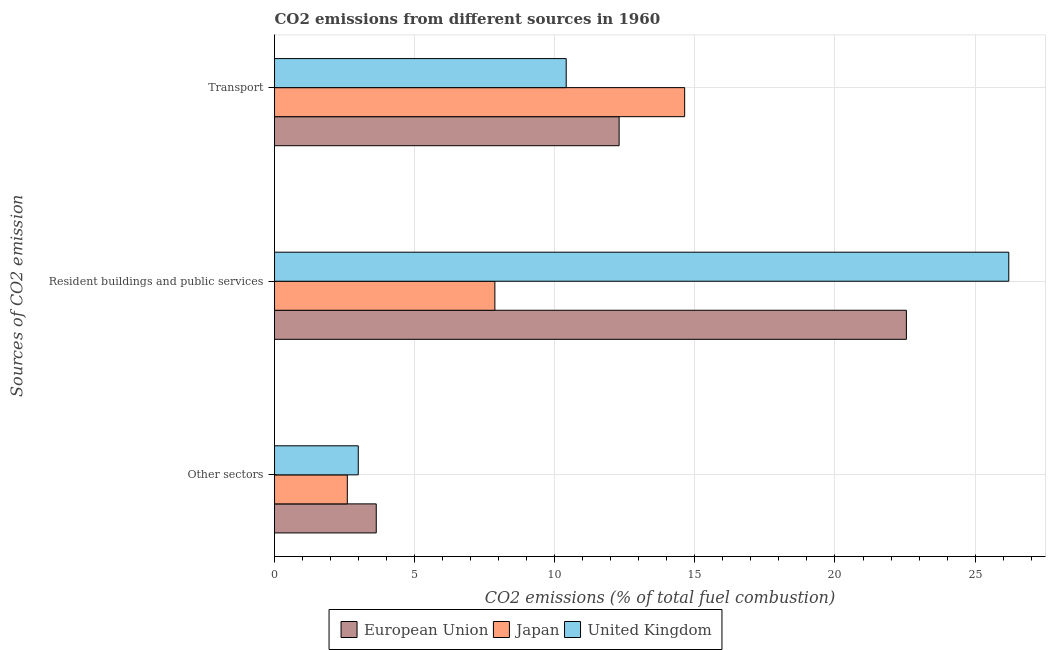What is the label of the 3rd group of bars from the top?
Provide a short and direct response. Other sectors. What is the percentage of co2 emissions from transport in European Union?
Offer a very short reply. 12.3. Across all countries, what is the maximum percentage of co2 emissions from resident buildings and public services?
Your response must be concise. 26.2. Across all countries, what is the minimum percentage of co2 emissions from resident buildings and public services?
Your response must be concise. 7.86. In which country was the percentage of co2 emissions from resident buildings and public services minimum?
Your answer should be compact. Japan. What is the total percentage of co2 emissions from other sectors in the graph?
Provide a short and direct response. 9.22. What is the difference between the percentage of co2 emissions from transport in United Kingdom and that in European Union?
Provide a short and direct response. -1.89. What is the difference between the percentage of co2 emissions from transport in European Union and the percentage of co2 emissions from resident buildings and public services in Japan?
Provide a short and direct response. 4.43. What is the average percentage of co2 emissions from resident buildings and public services per country?
Ensure brevity in your answer.  18.87. What is the difference between the percentage of co2 emissions from transport and percentage of co2 emissions from resident buildings and public services in United Kingdom?
Keep it short and to the point. -15.79. In how many countries, is the percentage of co2 emissions from other sectors greater than 9 %?
Offer a terse response. 0. What is the ratio of the percentage of co2 emissions from transport in European Union to that in United Kingdom?
Keep it short and to the point. 1.18. What is the difference between the highest and the second highest percentage of co2 emissions from resident buildings and public services?
Give a very brief answer. 3.65. What is the difference between the highest and the lowest percentage of co2 emissions from transport?
Provide a succinct answer. 4.23. In how many countries, is the percentage of co2 emissions from transport greater than the average percentage of co2 emissions from transport taken over all countries?
Your answer should be compact. 1. What does the 3rd bar from the bottom in Resident buildings and public services represents?
Make the answer very short. United Kingdom. How many countries are there in the graph?
Provide a succinct answer. 3. Are the values on the major ticks of X-axis written in scientific E-notation?
Provide a succinct answer. No. Does the graph contain any zero values?
Your answer should be very brief. No. What is the title of the graph?
Ensure brevity in your answer.  CO2 emissions from different sources in 1960. What is the label or title of the X-axis?
Your response must be concise. CO2 emissions (% of total fuel combustion). What is the label or title of the Y-axis?
Your answer should be very brief. Sources of CO2 emission. What is the CO2 emissions (% of total fuel combustion) of European Union in Other sectors?
Offer a very short reply. 3.63. What is the CO2 emissions (% of total fuel combustion) in Japan in Other sectors?
Provide a short and direct response. 2.6. What is the CO2 emissions (% of total fuel combustion) of United Kingdom in Other sectors?
Make the answer very short. 2.99. What is the CO2 emissions (% of total fuel combustion) in European Union in Resident buildings and public services?
Your answer should be compact. 22.55. What is the CO2 emissions (% of total fuel combustion) of Japan in Resident buildings and public services?
Offer a very short reply. 7.86. What is the CO2 emissions (% of total fuel combustion) of United Kingdom in Resident buildings and public services?
Offer a very short reply. 26.2. What is the CO2 emissions (% of total fuel combustion) in European Union in Transport?
Make the answer very short. 12.3. What is the CO2 emissions (% of total fuel combustion) in Japan in Transport?
Provide a succinct answer. 14.64. What is the CO2 emissions (% of total fuel combustion) in United Kingdom in Transport?
Give a very brief answer. 10.41. Across all Sources of CO2 emission, what is the maximum CO2 emissions (% of total fuel combustion) of European Union?
Provide a short and direct response. 22.55. Across all Sources of CO2 emission, what is the maximum CO2 emissions (% of total fuel combustion) in Japan?
Give a very brief answer. 14.64. Across all Sources of CO2 emission, what is the maximum CO2 emissions (% of total fuel combustion) in United Kingdom?
Ensure brevity in your answer.  26.2. Across all Sources of CO2 emission, what is the minimum CO2 emissions (% of total fuel combustion) in European Union?
Your response must be concise. 3.63. Across all Sources of CO2 emission, what is the minimum CO2 emissions (% of total fuel combustion) of Japan?
Give a very brief answer. 2.6. Across all Sources of CO2 emission, what is the minimum CO2 emissions (% of total fuel combustion) in United Kingdom?
Provide a short and direct response. 2.99. What is the total CO2 emissions (% of total fuel combustion) in European Union in the graph?
Your answer should be compact. 38.48. What is the total CO2 emissions (% of total fuel combustion) of Japan in the graph?
Offer a terse response. 25.1. What is the total CO2 emissions (% of total fuel combustion) of United Kingdom in the graph?
Ensure brevity in your answer.  39.6. What is the difference between the CO2 emissions (% of total fuel combustion) of European Union in Other sectors and that in Resident buildings and public services?
Your answer should be very brief. -18.92. What is the difference between the CO2 emissions (% of total fuel combustion) of Japan in Other sectors and that in Resident buildings and public services?
Provide a short and direct response. -5.27. What is the difference between the CO2 emissions (% of total fuel combustion) in United Kingdom in Other sectors and that in Resident buildings and public services?
Your answer should be very brief. -23.21. What is the difference between the CO2 emissions (% of total fuel combustion) in European Union in Other sectors and that in Transport?
Your response must be concise. -8.67. What is the difference between the CO2 emissions (% of total fuel combustion) in Japan in Other sectors and that in Transport?
Ensure brevity in your answer.  -12.04. What is the difference between the CO2 emissions (% of total fuel combustion) in United Kingdom in Other sectors and that in Transport?
Provide a succinct answer. -7.42. What is the difference between the CO2 emissions (% of total fuel combustion) of European Union in Resident buildings and public services and that in Transport?
Keep it short and to the point. 10.25. What is the difference between the CO2 emissions (% of total fuel combustion) in Japan in Resident buildings and public services and that in Transport?
Give a very brief answer. -6.77. What is the difference between the CO2 emissions (% of total fuel combustion) in United Kingdom in Resident buildings and public services and that in Transport?
Your answer should be very brief. 15.79. What is the difference between the CO2 emissions (% of total fuel combustion) in European Union in Other sectors and the CO2 emissions (% of total fuel combustion) in Japan in Resident buildings and public services?
Offer a very short reply. -4.23. What is the difference between the CO2 emissions (% of total fuel combustion) in European Union in Other sectors and the CO2 emissions (% of total fuel combustion) in United Kingdom in Resident buildings and public services?
Provide a short and direct response. -22.57. What is the difference between the CO2 emissions (% of total fuel combustion) in Japan in Other sectors and the CO2 emissions (% of total fuel combustion) in United Kingdom in Resident buildings and public services?
Your answer should be very brief. -23.61. What is the difference between the CO2 emissions (% of total fuel combustion) of European Union in Other sectors and the CO2 emissions (% of total fuel combustion) of Japan in Transport?
Give a very brief answer. -11.01. What is the difference between the CO2 emissions (% of total fuel combustion) in European Union in Other sectors and the CO2 emissions (% of total fuel combustion) in United Kingdom in Transport?
Your response must be concise. -6.78. What is the difference between the CO2 emissions (% of total fuel combustion) of Japan in Other sectors and the CO2 emissions (% of total fuel combustion) of United Kingdom in Transport?
Offer a very short reply. -7.81. What is the difference between the CO2 emissions (% of total fuel combustion) of European Union in Resident buildings and public services and the CO2 emissions (% of total fuel combustion) of Japan in Transport?
Offer a terse response. 7.91. What is the difference between the CO2 emissions (% of total fuel combustion) in European Union in Resident buildings and public services and the CO2 emissions (% of total fuel combustion) in United Kingdom in Transport?
Give a very brief answer. 12.14. What is the difference between the CO2 emissions (% of total fuel combustion) of Japan in Resident buildings and public services and the CO2 emissions (% of total fuel combustion) of United Kingdom in Transport?
Your response must be concise. -2.55. What is the average CO2 emissions (% of total fuel combustion) in European Union per Sources of CO2 emission?
Your response must be concise. 12.83. What is the average CO2 emissions (% of total fuel combustion) in Japan per Sources of CO2 emission?
Keep it short and to the point. 8.37. What is the average CO2 emissions (% of total fuel combustion) of United Kingdom per Sources of CO2 emission?
Offer a terse response. 13.2. What is the difference between the CO2 emissions (% of total fuel combustion) in European Union and CO2 emissions (% of total fuel combustion) in Japan in Other sectors?
Your answer should be very brief. 1.03. What is the difference between the CO2 emissions (% of total fuel combustion) of European Union and CO2 emissions (% of total fuel combustion) of United Kingdom in Other sectors?
Your response must be concise. 0.64. What is the difference between the CO2 emissions (% of total fuel combustion) in Japan and CO2 emissions (% of total fuel combustion) in United Kingdom in Other sectors?
Provide a short and direct response. -0.39. What is the difference between the CO2 emissions (% of total fuel combustion) in European Union and CO2 emissions (% of total fuel combustion) in Japan in Resident buildings and public services?
Keep it short and to the point. 14.69. What is the difference between the CO2 emissions (% of total fuel combustion) in European Union and CO2 emissions (% of total fuel combustion) in United Kingdom in Resident buildings and public services?
Offer a very short reply. -3.65. What is the difference between the CO2 emissions (% of total fuel combustion) of Japan and CO2 emissions (% of total fuel combustion) of United Kingdom in Resident buildings and public services?
Give a very brief answer. -18.34. What is the difference between the CO2 emissions (% of total fuel combustion) in European Union and CO2 emissions (% of total fuel combustion) in Japan in Transport?
Offer a very short reply. -2.34. What is the difference between the CO2 emissions (% of total fuel combustion) of European Union and CO2 emissions (% of total fuel combustion) of United Kingdom in Transport?
Your answer should be compact. 1.89. What is the difference between the CO2 emissions (% of total fuel combustion) of Japan and CO2 emissions (% of total fuel combustion) of United Kingdom in Transport?
Give a very brief answer. 4.23. What is the ratio of the CO2 emissions (% of total fuel combustion) in European Union in Other sectors to that in Resident buildings and public services?
Provide a short and direct response. 0.16. What is the ratio of the CO2 emissions (% of total fuel combustion) in Japan in Other sectors to that in Resident buildings and public services?
Your answer should be very brief. 0.33. What is the ratio of the CO2 emissions (% of total fuel combustion) of United Kingdom in Other sectors to that in Resident buildings and public services?
Make the answer very short. 0.11. What is the ratio of the CO2 emissions (% of total fuel combustion) of European Union in Other sectors to that in Transport?
Offer a terse response. 0.3. What is the ratio of the CO2 emissions (% of total fuel combustion) in Japan in Other sectors to that in Transport?
Your answer should be compact. 0.18. What is the ratio of the CO2 emissions (% of total fuel combustion) in United Kingdom in Other sectors to that in Transport?
Keep it short and to the point. 0.29. What is the ratio of the CO2 emissions (% of total fuel combustion) in European Union in Resident buildings and public services to that in Transport?
Provide a succinct answer. 1.83. What is the ratio of the CO2 emissions (% of total fuel combustion) in Japan in Resident buildings and public services to that in Transport?
Make the answer very short. 0.54. What is the ratio of the CO2 emissions (% of total fuel combustion) of United Kingdom in Resident buildings and public services to that in Transport?
Your answer should be very brief. 2.52. What is the difference between the highest and the second highest CO2 emissions (% of total fuel combustion) of European Union?
Keep it short and to the point. 10.25. What is the difference between the highest and the second highest CO2 emissions (% of total fuel combustion) of Japan?
Offer a terse response. 6.77. What is the difference between the highest and the second highest CO2 emissions (% of total fuel combustion) of United Kingdom?
Your answer should be very brief. 15.79. What is the difference between the highest and the lowest CO2 emissions (% of total fuel combustion) in European Union?
Keep it short and to the point. 18.92. What is the difference between the highest and the lowest CO2 emissions (% of total fuel combustion) of Japan?
Offer a terse response. 12.04. What is the difference between the highest and the lowest CO2 emissions (% of total fuel combustion) in United Kingdom?
Keep it short and to the point. 23.21. 